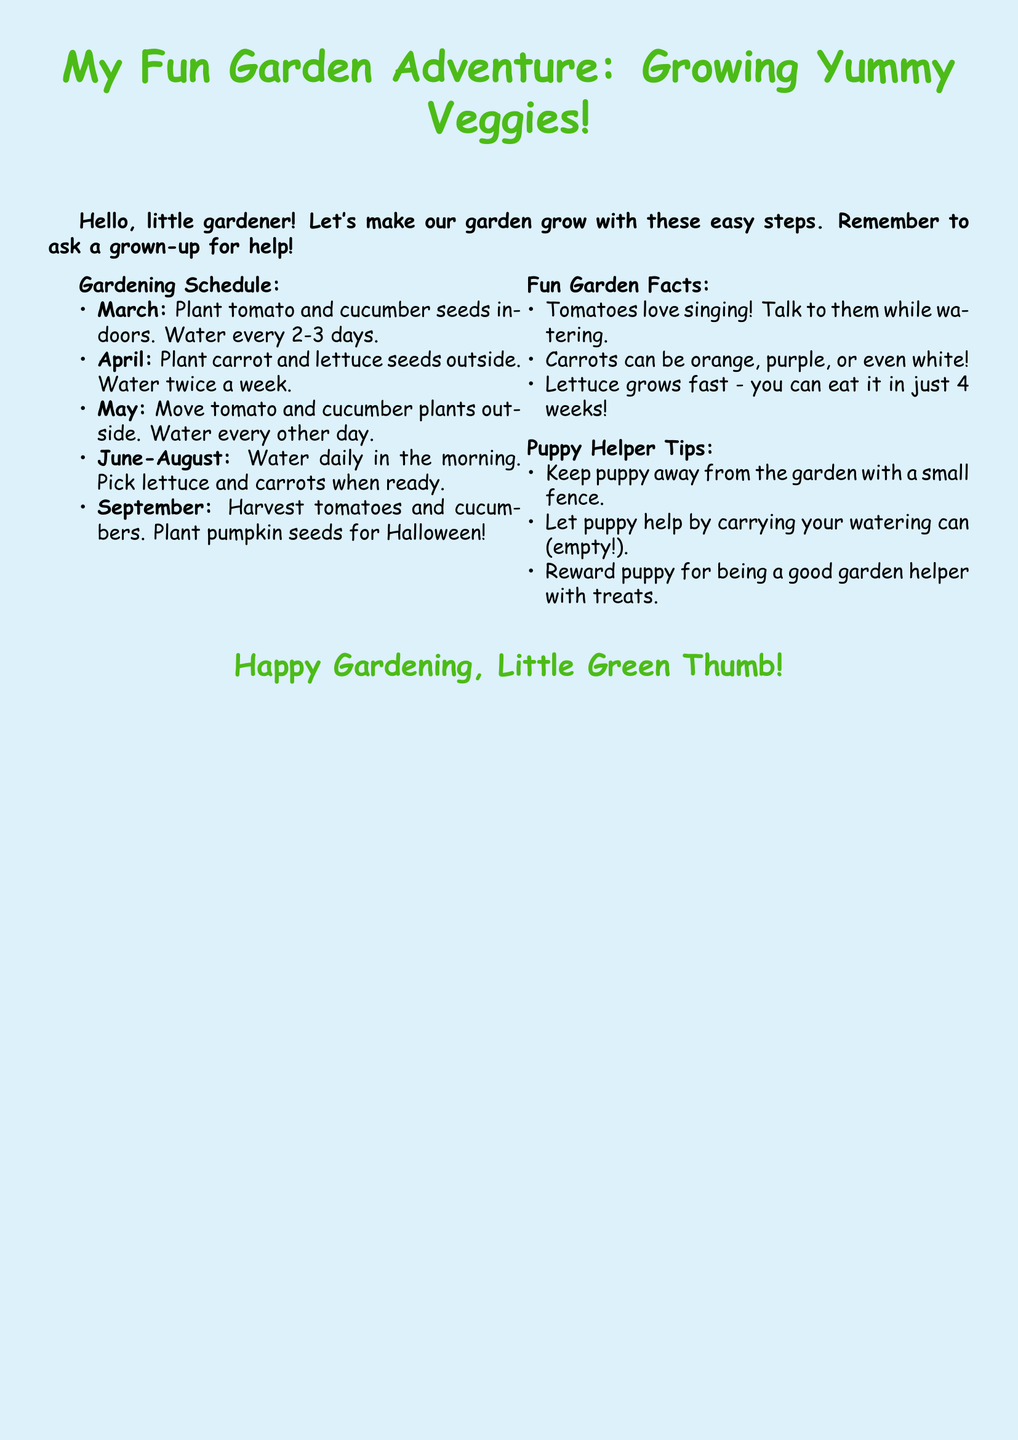What vegetables should be planted in March? The document states that tomato and cucumber seeds should be planted in March.
Answer: tomato and cucumber How often should you water plants in June-August? The document mentions watering daily in the morning during these months.
Answer: daily What month do you harvest tomatoes? According to the document, tomatoes are harvested in September.
Answer: September How long does it take to eat lettuce after planting? The document says you can eat lettuce in just 4 weeks after planting.
Answer: 4 weeks What should you keep away from the garden? The document advises keeping the puppy away from the garden with a small fence.
Answer: puppy What color can carrots be? The document specifies that carrots can be orange, purple, or even white.
Answer: orange, purple, white In which month are pumpkin seeds planted? The document indicates that pumpkin seeds should be planted in September for Halloween.
Answer: September How often do you water carrot and lettuce seeds? The document states that you should water them twice a week.
Answer: twice a week 